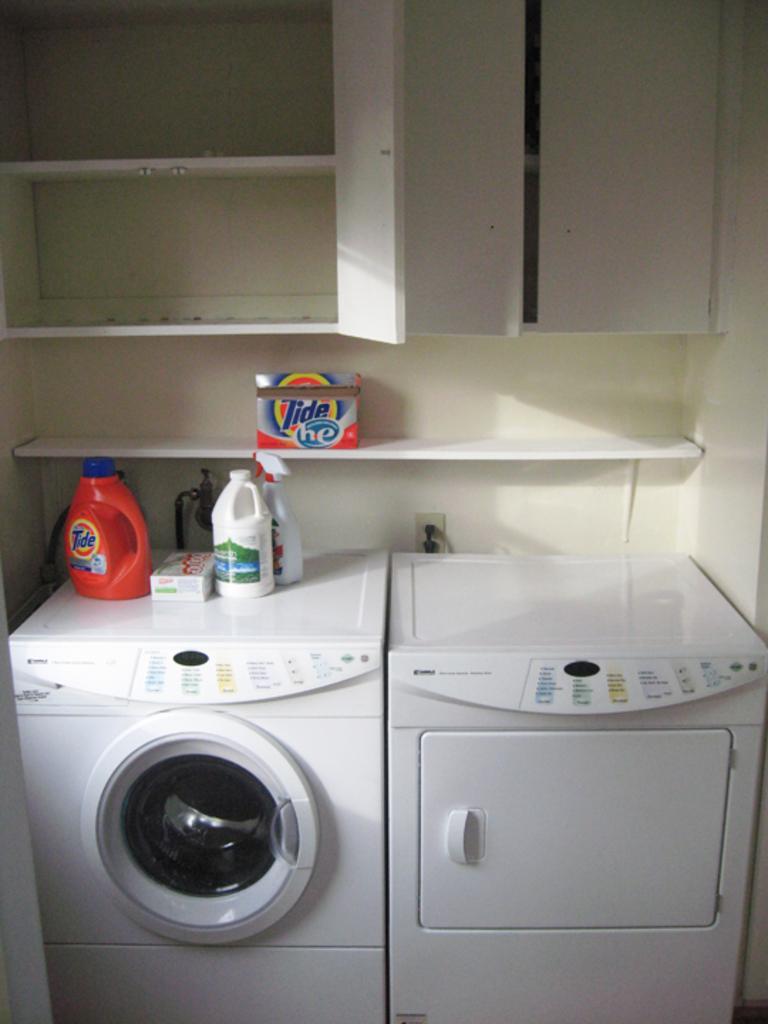Can you describe this image briefly? In this image in the center there is a washing machine which is white in colour and on the top of the washing machine there are bottles and there are cupboards. 